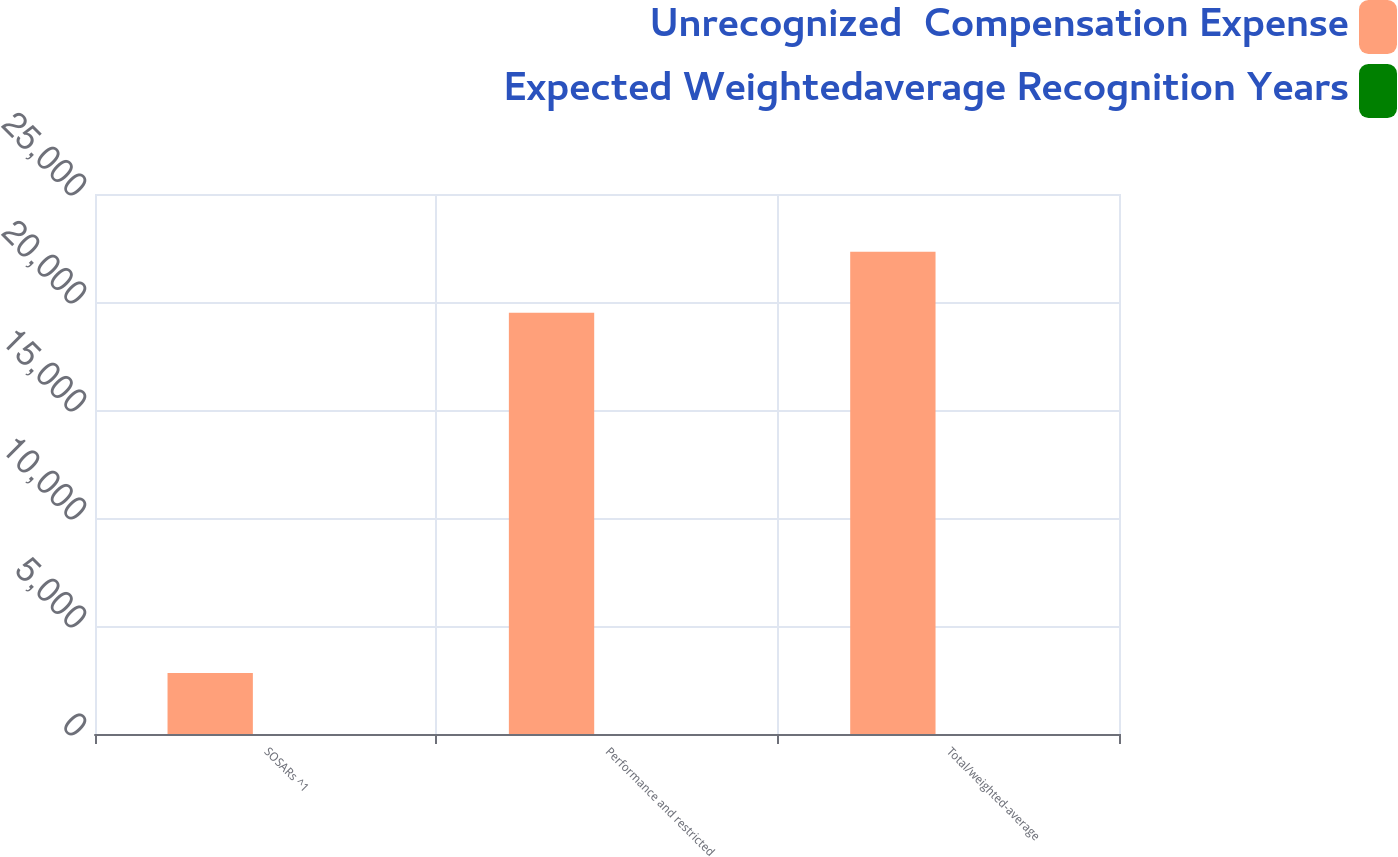<chart> <loc_0><loc_0><loc_500><loc_500><stacked_bar_chart><ecel><fcel>SOSARs ^1<fcel>Performance and restricted<fcel>Total/weighted-average<nl><fcel>Unrecognized  Compensation Expense<fcel>2825<fcel>19498<fcel>22323<nl><fcel>Expected Weightedaverage Recognition Years<fcel>1.6<fcel>2.6<fcel>2.5<nl></chart> 